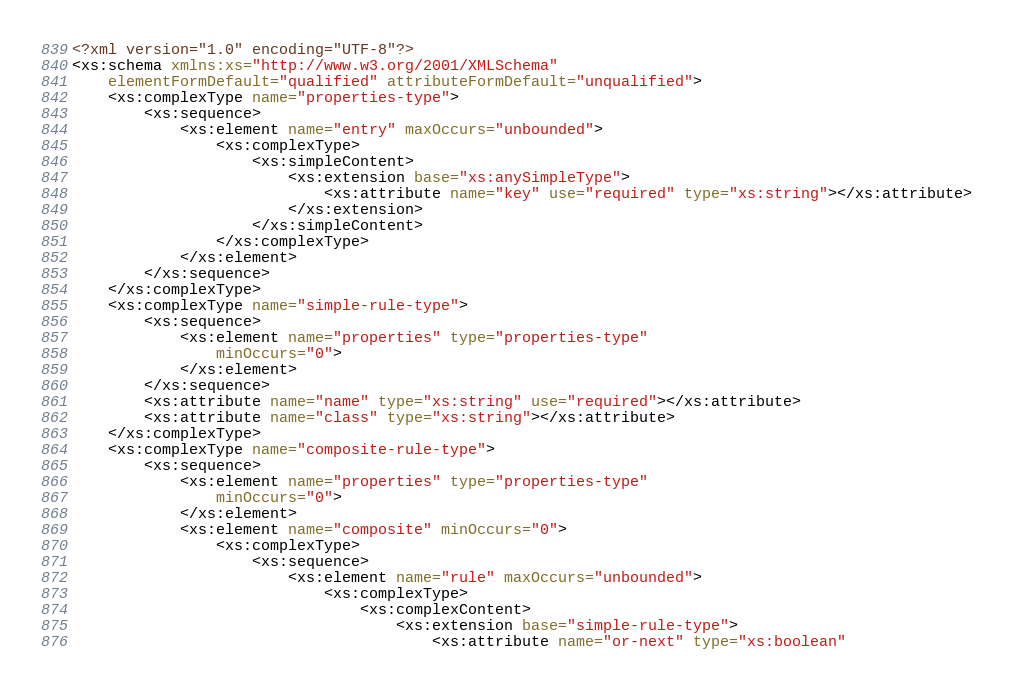Convert code to text. <code><loc_0><loc_0><loc_500><loc_500><_XML_><?xml version="1.0" encoding="UTF-8"?>
<xs:schema xmlns:xs="http://www.w3.org/2001/XMLSchema"
	elementFormDefault="qualified" attributeFormDefault="unqualified">
	<xs:complexType name="properties-type">
		<xs:sequence>
			<xs:element name="entry" maxOccurs="unbounded">
				<xs:complexType>
					<xs:simpleContent>
						<xs:extension base="xs:anySimpleType">
							<xs:attribute name="key" use="required" type="xs:string"></xs:attribute>
						</xs:extension>
					</xs:simpleContent>
				</xs:complexType>
			</xs:element>
		</xs:sequence>
	</xs:complexType>
	<xs:complexType name="simple-rule-type">
		<xs:sequence>
			<xs:element name="properties" type="properties-type"
				minOccurs="0">
			</xs:element>
		</xs:sequence>
		<xs:attribute name="name" type="xs:string" use="required"></xs:attribute>
		<xs:attribute name="class" type="xs:string"></xs:attribute>
	</xs:complexType>
	<xs:complexType name="composite-rule-type">
		<xs:sequence>
			<xs:element name="properties" type="properties-type"
				minOccurs="0">
			</xs:element>
			<xs:element name="composite" minOccurs="0">
				<xs:complexType>
					<xs:sequence>
						<xs:element name="rule" maxOccurs="unbounded">
							<xs:complexType>
								<xs:complexContent>
									<xs:extension base="simple-rule-type">
										<xs:attribute name="or-next" type="xs:boolean"</code> 